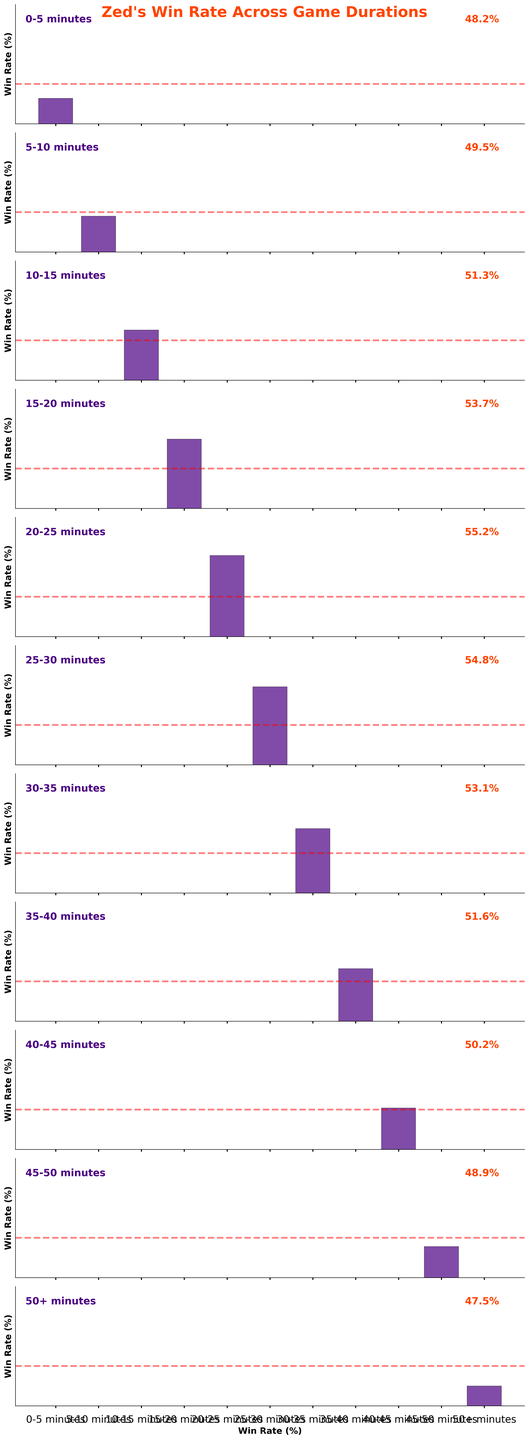Which game duration has the highest win rate? Look at the bars representing different game durations and find the one with the tallest bar. The 20-25 minutes duration has the tallest bar, indicating the highest win rate.
Answer: 20-25 minutes Does Zed's win rate ever drop below 50%? Observe the red dashed line at the 50% win rate mark and see if any bars fall below this line. The bars for 0-5, 45-50, and 50+ minutes are below 50%, indicating win rates lower than 50%.
Answer: Yes How does the win rate change between 25-30 and 30-35 minute intervals? Compare the heights of the bars for the 25-30 and 30-35 minute intervals. The win rate drops from 54.8% to 53.1%.
Answer: It decreases What is the average win rate for game durations from 15-20 to 25-30 minutes? Sum the win rates for the intervals 15-20, 20-25, and 25-30 minutes, then divide by the number of intervals: (53.7 + 55.2 + 54.8) / 3 = 54.5667%.
Answer: 54.57% Which game duration has a win rate closest to the overall median win rate? Identify the median win rate by listing all the win rates: 48.2, 49.5, 51.3, 53.7, 55.2, 54.8, 53.1, 51.6, 50.2, 48.9, 47.5. The median of this list is 51.3% which corresponds to the 10-15 minute interval.
Answer: 10-15 minutes Does Zed's win rate increase or decrease over time after the peak at 20-25 minutes? Observe the trend in the heights of the bars after the 20-25 minute mark. The bars decrease in height, indicating a decreasing win rate after this peak.
Answer: Decrease Which time interval shows the most significant increase in win rate from the previous interval? Compare the differences in win rates between consecutive intervals. The increase from 15-20 minutes (53.7%) to 20-25 minutes (55.2%) is the most significant, which is 1.5%.
Answer: 15-20 to 20-25 minutes What is the win rate at the 25-30 minute interval? Look at the bar labeled 25-30 minutes and read the win rate value next to it or on the bar itself. The win rate is 54.8%.
Answer: 54.8% How much higher is the win rate at 15-20 minutes compared to the 45-50 minute interval? Subtract the win rate at the 45-50 minute interval from the win rate at the 15-20 minute interval: 53.7% - 48.9% = 4.8%.
Answer: 4.8% What is the trend in win rate from 10-15 to 20-25 minutes? Observe the heights of the bars for intervals 10-15, 15-20, and 20-25 minutes. The bars show a consistent increase in win rate.
Answer: Increase 